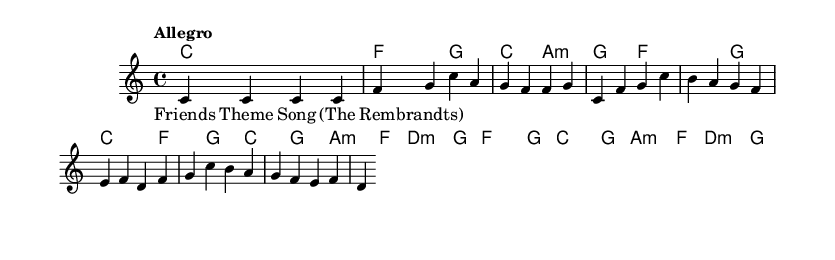What is the key signature of this music? The key signature is C major, which has no sharps or flats.
Answer: C major What is the time signature of this music? The time signature is indicated by the '4/4' notation, which means there are four beats in each measure and the quarter note gets one beat.
Answer: 4/4 What is the tempo marking of this piece? The tempo marking is "Allegro", which indicates a fast and lively tempo.
Answer: Allegro What is the first chord in the harmonies? The first chord is a C major chord, represented by the letter 'c' in the chord mode.
Answer: C How many measures are in the melody section? The melody consists of 4 measures, which can be counted from the notation provided.
Answer: 4 Describe the overall structure of the song in one phrase. The song has a theme based on the Friends sitcom, and it features a straightforward singable melody accompanied by harmonies.
Answer: Friends Theme Song What type of music does this score represent? This score represents a soundtrack piece, specifically a theme song from a popular 90s sitcom.
Answer: Soundtrack 